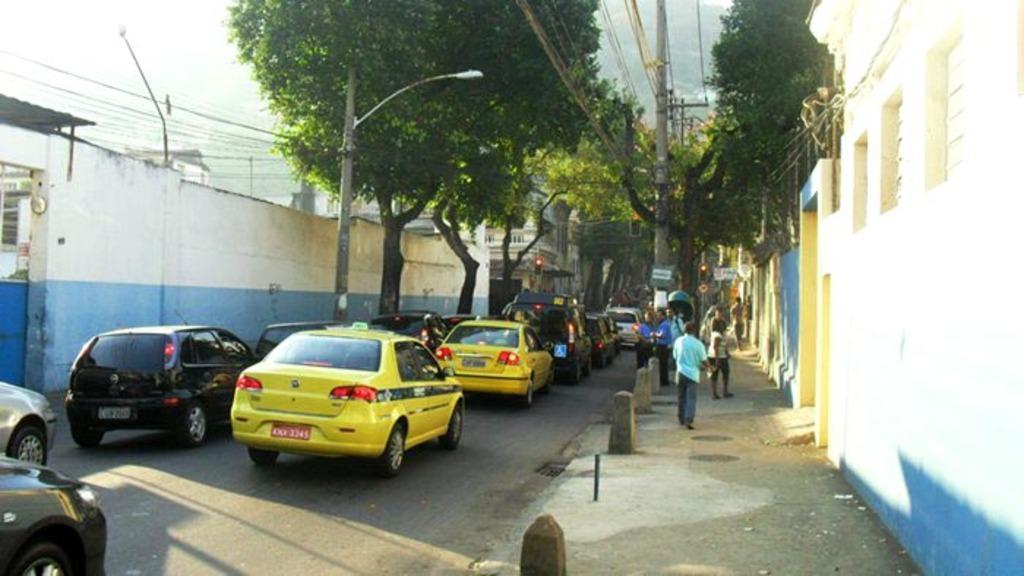Please provide a concise description of this image. In this picture we can see few vehicles on the road and we can find few people on the right side of the image, in the background we can see few trees, poles, cables and buildings. 